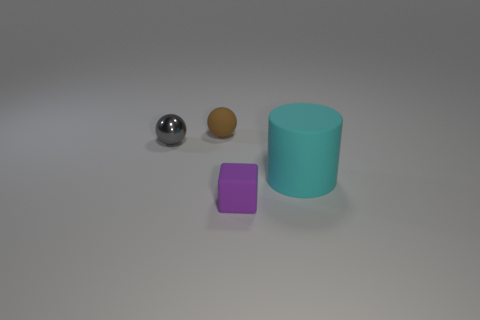Is there a rubber block that has the same color as the metal sphere?
Keep it short and to the point. No. The tiny object that is both in front of the small matte sphere and on the right side of the small gray metallic object has what shape?
Provide a short and direct response. Cube. How many gray spheres have the same material as the tiny gray thing?
Provide a short and direct response. 0. Are there fewer matte balls right of the cyan rubber thing than cylinders left of the matte sphere?
Make the answer very short. No. What material is the small brown object that is left of the tiny thing that is to the right of the tiny rubber thing that is behind the large rubber cylinder?
Offer a terse response. Rubber. There is a rubber object that is behind the tiny cube and in front of the brown rubber object; what is its size?
Ensure brevity in your answer.  Large. How many blocks are either green rubber things or purple things?
Ensure brevity in your answer.  1. There is a shiny ball that is the same size as the cube; what is its color?
Ensure brevity in your answer.  Gray. Are there any other things that are the same shape as the large thing?
Your response must be concise. No. There is a matte thing that is the same shape as the gray shiny object; what is its color?
Give a very brief answer. Brown. 